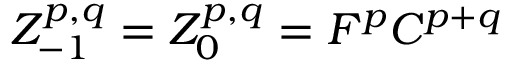<formula> <loc_0><loc_0><loc_500><loc_500>Z _ { - 1 } ^ { p , q } = Z _ { 0 } ^ { p , q } = F ^ { p } C ^ { p + q }</formula> 